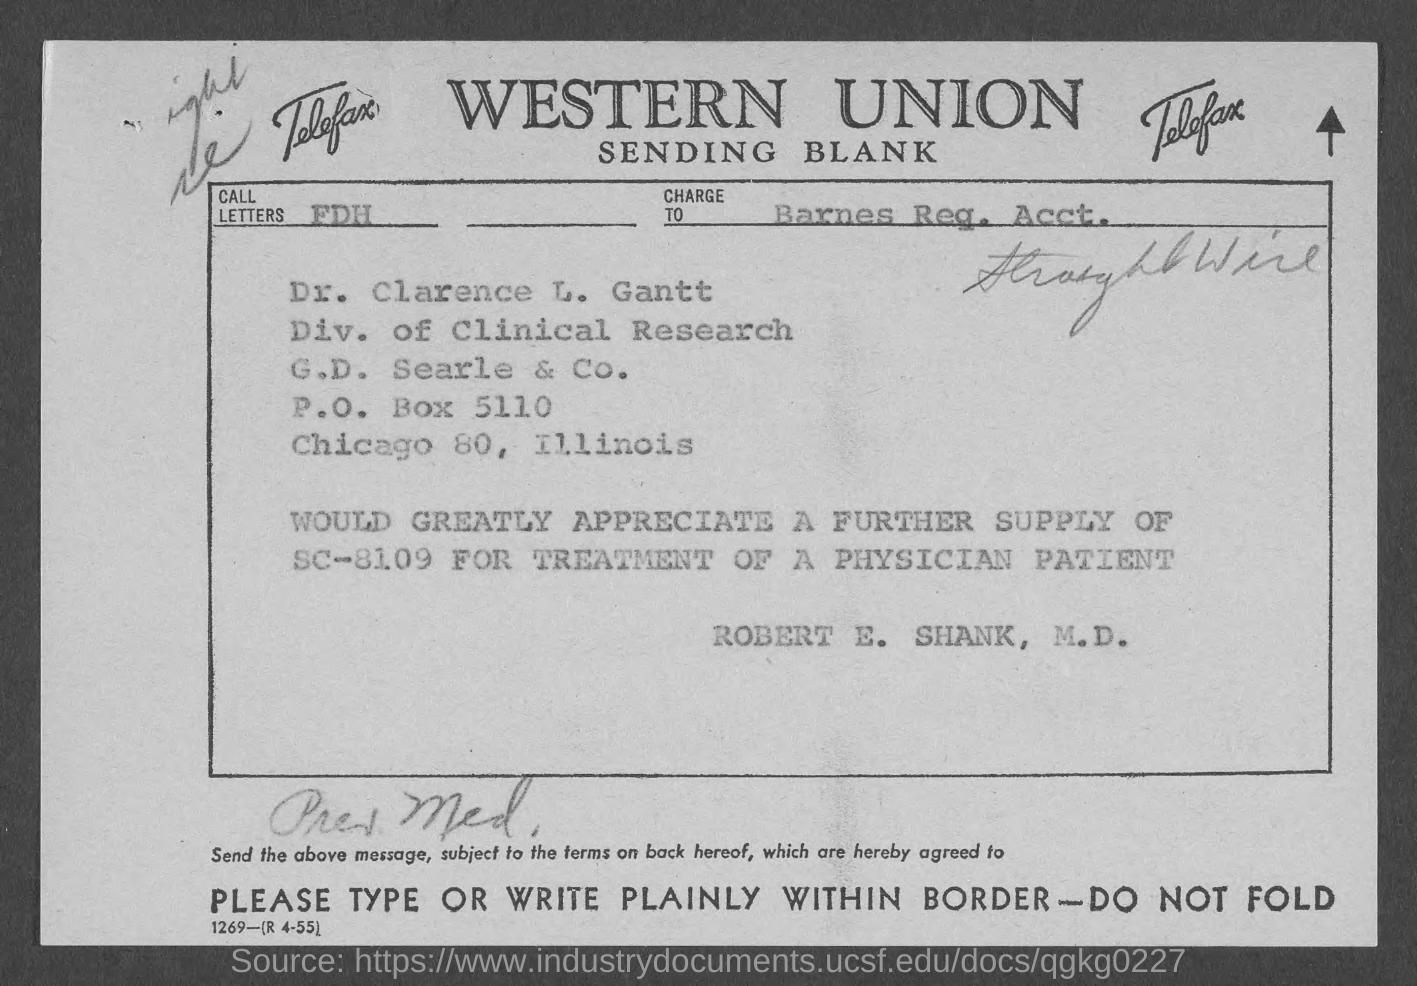Specify some key components in this picture. The call letters are FDH. 